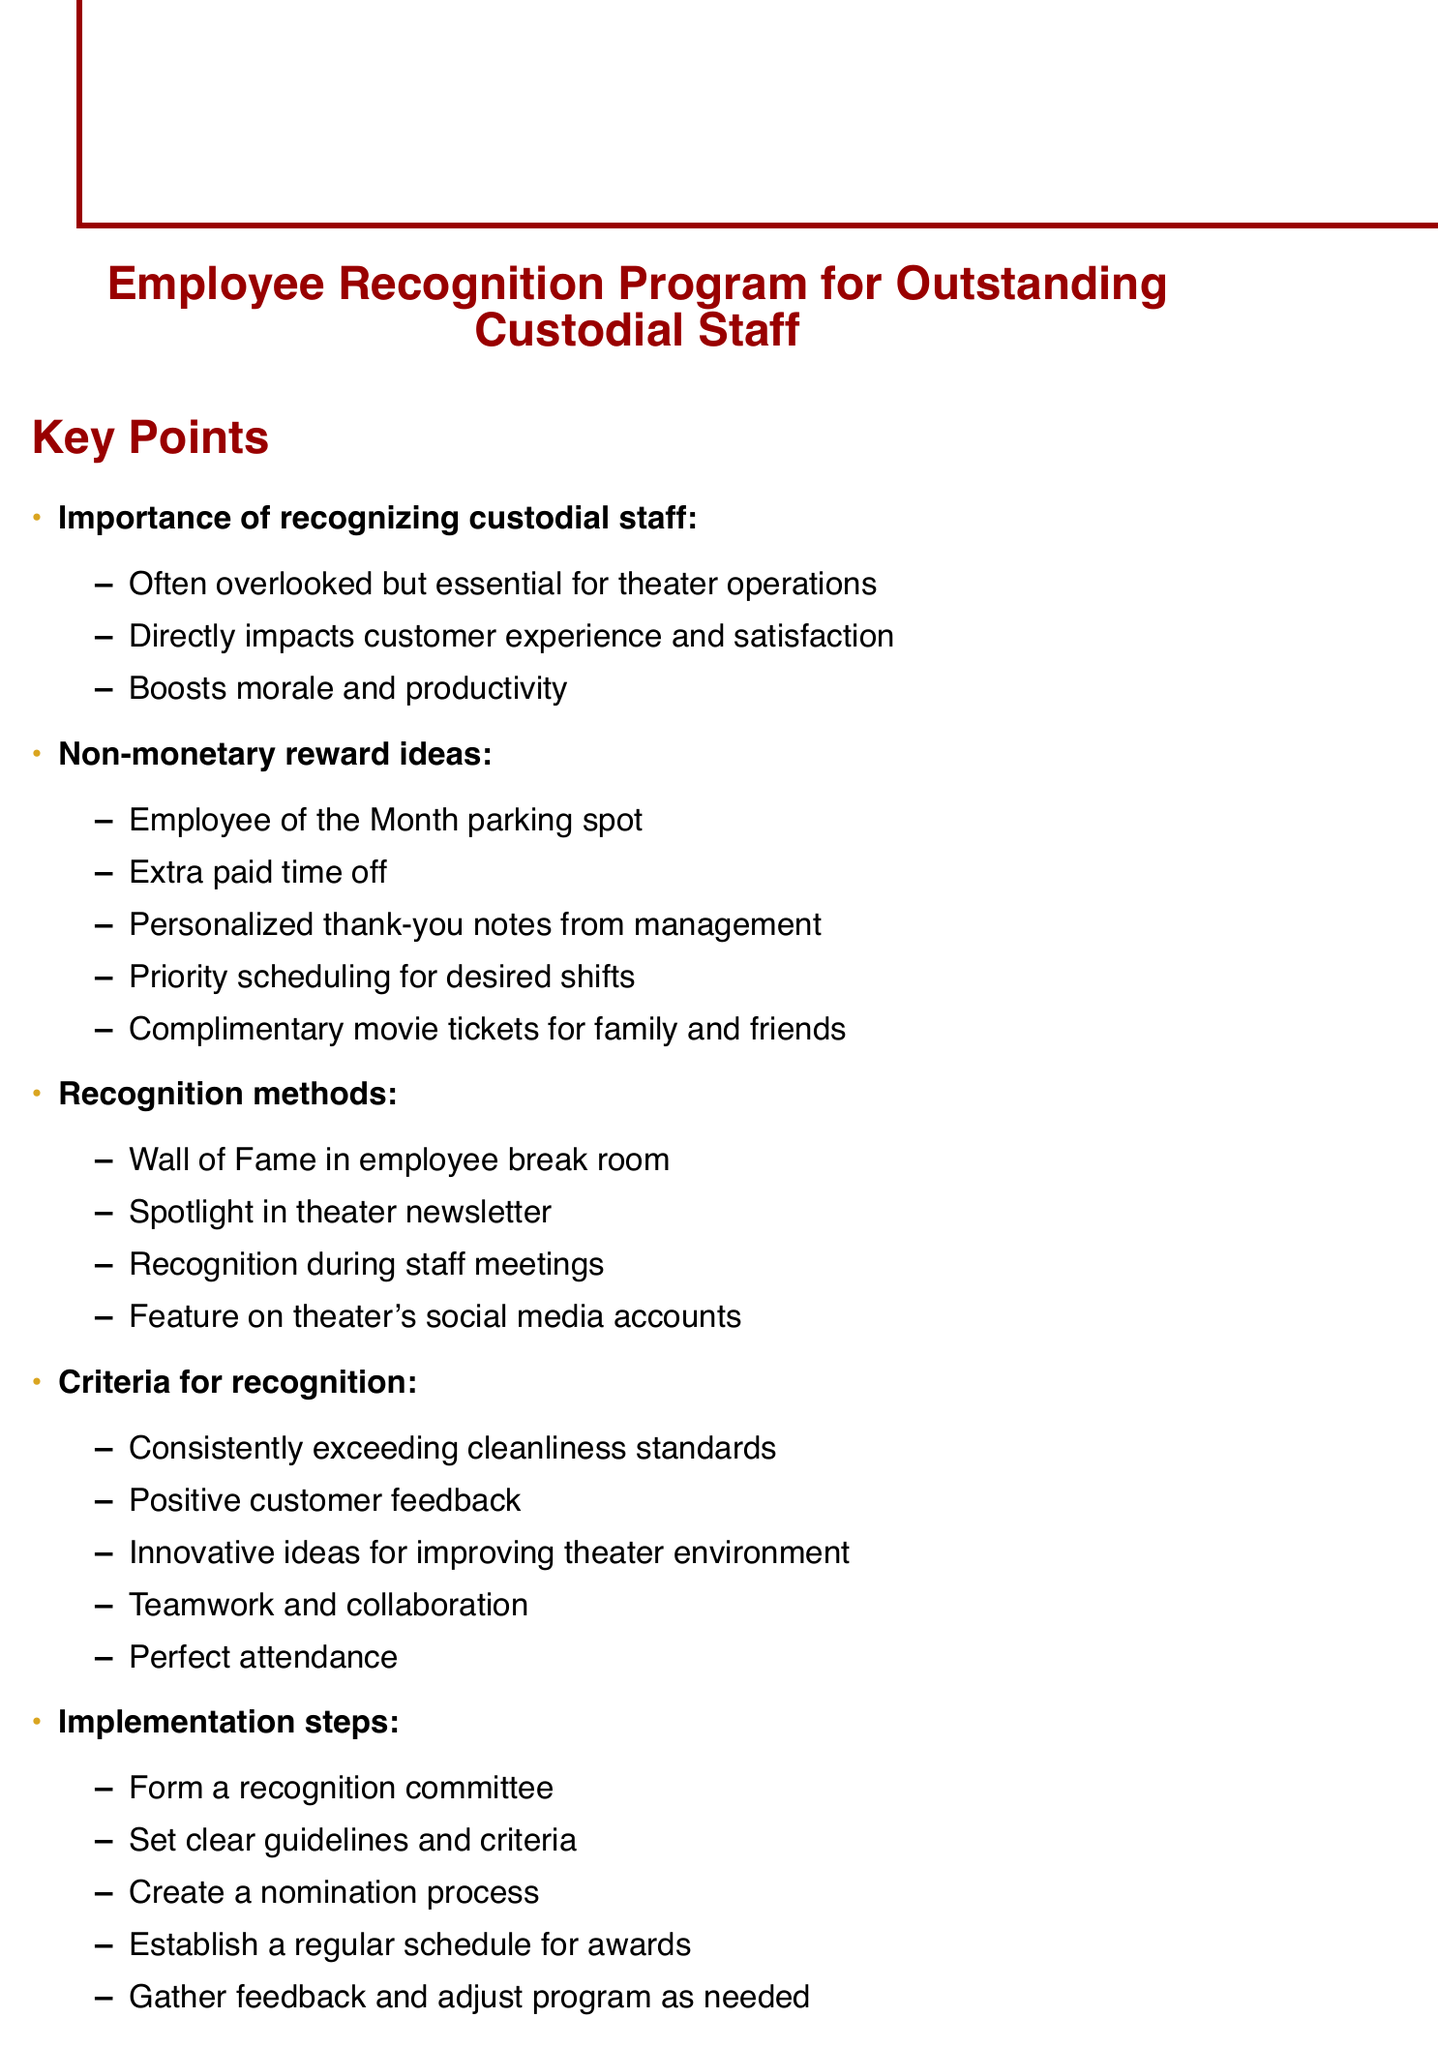What is the title of the document? The title is clearly stated at the beginning of the document.
Answer: Employee Recognition Program for Outstanding Custodial Staff How many non-monetary reward ideas are listed? The number of non-monetary reward ideas can be counted in the respective section.
Answer: Five What is one method of recognition mentioned? This can be found in the section about recognition methods.
Answer: Wall of Fame in employee break room What are the criteria for recognition? The document specifies several criteria for recognition, which can be listed.
Answer: Consistently exceeding cleanliness standards Who created the document? The end of the document attributes the creation to a specific role.
Answer: Theater Manager What example is given for Regal Cinemas? The specific award program for Regal Cinemas is mentioned in the examples section.
Answer: Spotlight on Excellence Which non-monetary reward includes extra time? This is explicitly mentioned as one of the reward ideas.
Answer: Extra paid time off What is one implementation step mentioned? The implementation steps are clearly line-itemed in the document.
Answer: Form a recognition committee What frequency is the AMC Theatres recognition program? This can be found in the example description for AMC Theatres.
Answer: Quarterly 